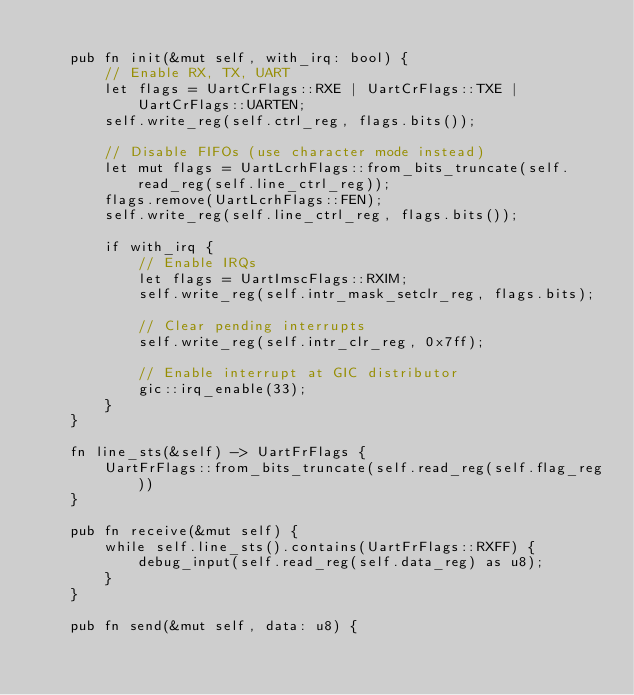Convert code to text. <code><loc_0><loc_0><loc_500><loc_500><_Rust_>
    pub fn init(&mut self, with_irq: bool) {
        // Enable RX, TX, UART
        let flags = UartCrFlags::RXE | UartCrFlags::TXE | UartCrFlags::UARTEN;
        self.write_reg(self.ctrl_reg, flags.bits());

        // Disable FIFOs (use character mode instead)
        let mut flags = UartLcrhFlags::from_bits_truncate(self.read_reg(self.line_ctrl_reg));
        flags.remove(UartLcrhFlags::FEN);
        self.write_reg(self.line_ctrl_reg, flags.bits());

        if with_irq {
            // Enable IRQs
            let flags = UartImscFlags::RXIM;
            self.write_reg(self.intr_mask_setclr_reg, flags.bits);

            // Clear pending interrupts
            self.write_reg(self.intr_clr_reg, 0x7ff);

            // Enable interrupt at GIC distributor
            gic::irq_enable(33);
        }
    }

    fn line_sts(&self) -> UartFrFlags {
        UartFrFlags::from_bits_truncate(self.read_reg(self.flag_reg))
    }

    pub fn receive(&mut self) {
        while self.line_sts().contains(UartFrFlags::RXFF) {
            debug_input(self.read_reg(self.data_reg) as u8);
        }
    }

    pub fn send(&mut self, data: u8) {</code> 